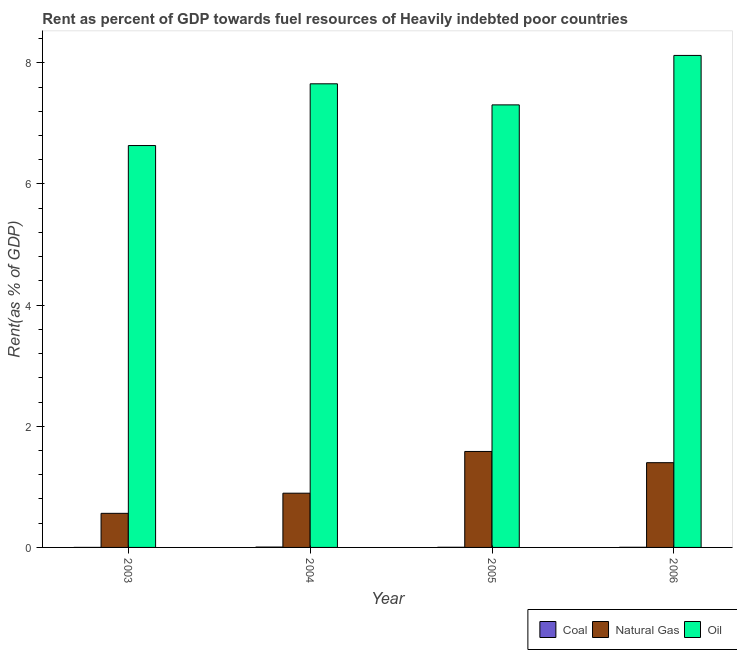How many different coloured bars are there?
Keep it short and to the point. 3. Are the number of bars per tick equal to the number of legend labels?
Your answer should be very brief. Yes. Are the number of bars on each tick of the X-axis equal?
Offer a terse response. Yes. How many bars are there on the 3rd tick from the right?
Ensure brevity in your answer.  3. In how many cases, is the number of bars for a given year not equal to the number of legend labels?
Give a very brief answer. 0. What is the rent towards natural gas in 2003?
Your answer should be compact. 0.56. Across all years, what is the maximum rent towards oil?
Offer a terse response. 8.12. Across all years, what is the minimum rent towards coal?
Offer a terse response. 0. In which year was the rent towards oil maximum?
Your answer should be compact. 2006. What is the total rent towards coal in the graph?
Your answer should be compact. 0.01. What is the difference between the rent towards natural gas in 2004 and that in 2006?
Provide a short and direct response. -0.5. What is the difference between the rent towards natural gas in 2003 and the rent towards coal in 2006?
Ensure brevity in your answer.  -0.84. What is the average rent towards oil per year?
Your response must be concise. 7.43. What is the ratio of the rent towards natural gas in 2003 to that in 2004?
Provide a short and direct response. 0.63. Is the difference between the rent towards oil in 2003 and 2006 greater than the difference between the rent towards coal in 2003 and 2006?
Your answer should be very brief. No. What is the difference between the highest and the second highest rent towards oil?
Provide a succinct answer. 0.47. What is the difference between the highest and the lowest rent towards natural gas?
Your response must be concise. 1.02. What does the 2nd bar from the left in 2004 represents?
Offer a terse response. Natural Gas. What does the 2nd bar from the right in 2006 represents?
Your response must be concise. Natural Gas. How many bars are there?
Your answer should be very brief. 12. Are all the bars in the graph horizontal?
Your response must be concise. No. What is the difference between two consecutive major ticks on the Y-axis?
Offer a terse response. 2. Are the values on the major ticks of Y-axis written in scientific E-notation?
Ensure brevity in your answer.  No. Does the graph contain any zero values?
Provide a succinct answer. No. Does the graph contain grids?
Your answer should be compact. No. Where does the legend appear in the graph?
Ensure brevity in your answer.  Bottom right. How are the legend labels stacked?
Your response must be concise. Horizontal. What is the title of the graph?
Offer a terse response. Rent as percent of GDP towards fuel resources of Heavily indebted poor countries. What is the label or title of the Y-axis?
Provide a succinct answer. Rent(as % of GDP). What is the Rent(as % of GDP) in Coal in 2003?
Your answer should be very brief. 0. What is the Rent(as % of GDP) in Natural Gas in 2003?
Offer a terse response. 0.56. What is the Rent(as % of GDP) in Oil in 2003?
Ensure brevity in your answer.  6.63. What is the Rent(as % of GDP) in Coal in 2004?
Your answer should be compact. 0.01. What is the Rent(as % of GDP) in Natural Gas in 2004?
Offer a terse response. 0.9. What is the Rent(as % of GDP) in Oil in 2004?
Your answer should be very brief. 7.65. What is the Rent(as % of GDP) in Coal in 2005?
Offer a terse response. 0. What is the Rent(as % of GDP) of Natural Gas in 2005?
Make the answer very short. 1.58. What is the Rent(as % of GDP) in Oil in 2005?
Keep it short and to the point. 7.31. What is the Rent(as % of GDP) in Coal in 2006?
Provide a short and direct response. 0. What is the Rent(as % of GDP) of Natural Gas in 2006?
Your answer should be very brief. 1.4. What is the Rent(as % of GDP) of Oil in 2006?
Your answer should be very brief. 8.12. Across all years, what is the maximum Rent(as % of GDP) of Coal?
Give a very brief answer. 0.01. Across all years, what is the maximum Rent(as % of GDP) of Natural Gas?
Ensure brevity in your answer.  1.58. Across all years, what is the maximum Rent(as % of GDP) of Oil?
Offer a very short reply. 8.12. Across all years, what is the minimum Rent(as % of GDP) in Coal?
Your answer should be compact. 0. Across all years, what is the minimum Rent(as % of GDP) in Natural Gas?
Offer a terse response. 0.56. Across all years, what is the minimum Rent(as % of GDP) of Oil?
Your response must be concise. 6.63. What is the total Rent(as % of GDP) in Coal in the graph?
Keep it short and to the point. 0.01. What is the total Rent(as % of GDP) of Natural Gas in the graph?
Your response must be concise. 4.44. What is the total Rent(as % of GDP) in Oil in the graph?
Keep it short and to the point. 29.71. What is the difference between the Rent(as % of GDP) in Coal in 2003 and that in 2004?
Ensure brevity in your answer.  -0.01. What is the difference between the Rent(as % of GDP) in Natural Gas in 2003 and that in 2004?
Provide a short and direct response. -0.33. What is the difference between the Rent(as % of GDP) of Oil in 2003 and that in 2004?
Keep it short and to the point. -1.02. What is the difference between the Rent(as % of GDP) in Coal in 2003 and that in 2005?
Your answer should be compact. -0. What is the difference between the Rent(as % of GDP) of Natural Gas in 2003 and that in 2005?
Ensure brevity in your answer.  -1.02. What is the difference between the Rent(as % of GDP) in Oil in 2003 and that in 2005?
Offer a terse response. -0.67. What is the difference between the Rent(as % of GDP) of Coal in 2003 and that in 2006?
Your answer should be compact. -0. What is the difference between the Rent(as % of GDP) in Natural Gas in 2003 and that in 2006?
Provide a short and direct response. -0.84. What is the difference between the Rent(as % of GDP) in Oil in 2003 and that in 2006?
Provide a succinct answer. -1.49. What is the difference between the Rent(as % of GDP) in Coal in 2004 and that in 2005?
Give a very brief answer. 0. What is the difference between the Rent(as % of GDP) of Natural Gas in 2004 and that in 2005?
Offer a very short reply. -0.69. What is the difference between the Rent(as % of GDP) of Oil in 2004 and that in 2005?
Provide a short and direct response. 0.35. What is the difference between the Rent(as % of GDP) of Coal in 2004 and that in 2006?
Keep it short and to the point. 0. What is the difference between the Rent(as % of GDP) in Natural Gas in 2004 and that in 2006?
Provide a succinct answer. -0.5. What is the difference between the Rent(as % of GDP) in Oil in 2004 and that in 2006?
Provide a succinct answer. -0.47. What is the difference between the Rent(as % of GDP) of Natural Gas in 2005 and that in 2006?
Offer a very short reply. 0.19. What is the difference between the Rent(as % of GDP) of Oil in 2005 and that in 2006?
Your response must be concise. -0.82. What is the difference between the Rent(as % of GDP) of Coal in 2003 and the Rent(as % of GDP) of Natural Gas in 2004?
Ensure brevity in your answer.  -0.9. What is the difference between the Rent(as % of GDP) of Coal in 2003 and the Rent(as % of GDP) of Oil in 2004?
Offer a terse response. -7.65. What is the difference between the Rent(as % of GDP) in Natural Gas in 2003 and the Rent(as % of GDP) in Oil in 2004?
Your answer should be compact. -7.09. What is the difference between the Rent(as % of GDP) of Coal in 2003 and the Rent(as % of GDP) of Natural Gas in 2005?
Your response must be concise. -1.58. What is the difference between the Rent(as % of GDP) of Coal in 2003 and the Rent(as % of GDP) of Oil in 2005?
Your answer should be very brief. -7.3. What is the difference between the Rent(as % of GDP) of Natural Gas in 2003 and the Rent(as % of GDP) of Oil in 2005?
Ensure brevity in your answer.  -6.74. What is the difference between the Rent(as % of GDP) of Coal in 2003 and the Rent(as % of GDP) of Natural Gas in 2006?
Keep it short and to the point. -1.4. What is the difference between the Rent(as % of GDP) in Coal in 2003 and the Rent(as % of GDP) in Oil in 2006?
Offer a very short reply. -8.12. What is the difference between the Rent(as % of GDP) of Natural Gas in 2003 and the Rent(as % of GDP) of Oil in 2006?
Provide a short and direct response. -7.56. What is the difference between the Rent(as % of GDP) of Coal in 2004 and the Rent(as % of GDP) of Natural Gas in 2005?
Provide a succinct answer. -1.58. What is the difference between the Rent(as % of GDP) of Coal in 2004 and the Rent(as % of GDP) of Oil in 2005?
Your answer should be compact. -7.3. What is the difference between the Rent(as % of GDP) of Natural Gas in 2004 and the Rent(as % of GDP) of Oil in 2005?
Make the answer very short. -6.41. What is the difference between the Rent(as % of GDP) of Coal in 2004 and the Rent(as % of GDP) of Natural Gas in 2006?
Give a very brief answer. -1.39. What is the difference between the Rent(as % of GDP) of Coal in 2004 and the Rent(as % of GDP) of Oil in 2006?
Give a very brief answer. -8.12. What is the difference between the Rent(as % of GDP) in Natural Gas in 2004 and the Rent(as % of GDP) in Oil in 2006?
Your response must be concise. -7.23. What is the difference between the Rent(as % of GDP) in Coal in 2005 and the Rent(as % of GDP) in Natural Gas in 2006?
Your answer should be compact. -1.4. What is the difference between the Rent(as % of GDP) in Coal in 2005 and the Rent(as % of GDP) in Oil in 2006?
Your response must be concise. -8.12. What is the difference between the Rent(as % of GDP) in Natural Gas in 2005 and the Rent(as % of GDP) in Oil in 2006?
Offer a terse response. -6.54. What is the average Rent(as % of GDP) of Coal per year?
Your response must be concise. 0. What is the average Rent(as % of GDP) in Natural Gas per year?
Provide a succinct answer. 1.11. What is the average Rent(as % of GDP) in Oil per year?
Your response must be concise. 7.43. In the year 2003, what is the difference between the Rent(as % of GDP) of Coal and Rent(as % of GDP) of Natural Gas?
Ensure brevity in your answer.  -0.56. In the year 2003, what is the difference between the Rent(as % of GDP) in Coal and Rent(as % of GDP) in Oil?
Give a very brief answer. -6.63. In the year 2003, what is the difference between the Rent(as % of GDP) in Natural Gas and Rent(as % of GDP) in Oil?
Give a very brief answer. -6.07. In the year 2004, what is the difference between the Rent(as % of GDP) of Coal and Rent(as % of GDP) of Natural Gas?
Your answer should be compact. -0.89. In the year 2004, what is the difference between the Rent(as % of GDP) of Coal and Rent(as % of GDP) of Oil?
Your answer should be very brief. -7.65. In the year 2004, what is the difference between the Rent(as % of GDP) of Natural Gas and Rent(as % of GDP) of Oil?
Provide a succinct answer. -6.76. In the year 2005, what is the difference between the Rent(as % of GDP) of Coal and Rent(as % of GDP) of Natural Gas?
Make the answer very short. -1.58. In the year 2005, what is the difference between the Rent(as % of GDP) of Coal and Rent(as % of GDP) of Oil?
Keep it short and to the point. -7.3. In the year 2005, what is the difference between the Rent(as % of GDP) of Natural Gas and Rent(as % of GDP) of Oil?
Ensure brevity in your answer.  -5.72. In the year 2006, what is the difference between the Rent(as % of GDP) in Coal and Rent(as % of GDP) in Natural Gas?
Offer a very short reply. -1.4. In the year 2006, what is the difference between the Rent(as % of GDP) in Coal and Rent(as % of GDP) in Oil?
Your answer should be compact. -8.12. In the year 2006, what is the difference between the Rent(as % of GDP) in Natural Gas and Rent(as % of GDP) in Oil?
Give a very brief answer. -6.72. What is the ratio of the Rent(as % of GDP) of Coal in 2003 to that in 2004?
Provide a short and direct response. 0.02. What is the ratio of the Rent(as % of GDP) of Natural Gas in 2003 to that in 2004?
Offer a terse response. 0.63. What is the ratio of the Rent(as % of GDP) of Oil in 2003 to that in 2004?
Offer a very short reply. 0.87. What is the ratio of the Rent(as % of GDP) of Coal in 2003 to that in 2005?
Provide a succinct answer. 0.04. What is the ratio of the Rent(as % of GDP) of Natural Gas in 2003 to that in 2005?
Give a very brief answer. 0.36. What is the ratio of the Rent(as % of GDP) in Oil in 2003 to that in 2005?
Offer a terse response. 0.91. What is the ratio of the Rent(as % of GDP) of Coal in 2003 to that in 2006?
Make the answer very short. 0.05. What is the ratio of the Rent(as % of GDP) of Natural Gas in 2003 to that in 2006?
Ensure brevity in your answer.  0.4. What is the ratio of the Rent(as % of GDP) of Oil in 2003 to that in 2006?
Offer a very short reply. 0.82. What is the ratio of the Rent(as % of GDP) of Coal in 2004 to that in 2005?
Your response must be concise. 2.24. What is the ratio of the Rent(as % of GDP) of Natural Gas in 2004 to that in 2005?
Your answer should be compact. 0.57. What is the ratio of the Rent(as % of GDP) of Oil in 2004 to that in 2005?
Your answer should be very brief. 1.05. What is the ratio of the Rent(as % of GDP) of Coal in 2004 to that in 2006?
Provide a succinct answer. 2.52. What is the ratio of the Rent(as % of GDP) in Natural Gas in 2004 to that in 2006?
Your answer should be very brief. 0.64. What is the ratio of the Rent(as % of GDP) of Oil in 2004 to that in 2006?
Make the answer very short. 0.94. What is the ratio of the Rent(as % of GDP) in Coal in 2005 to that in 2006?
Your answer should be compact. 1.12. What is the ratio of the Rent(as % of GDP) in Natural Gas in 2005 to that in 2006?
Your answer should be very brief. 1.13. What is the ratio of the Rent(as % of GDP) in Oil in 2005 to that in 2006?
Keep it short and to the point. 0.9. What is the difference between the highest and the second highest Rent(as % of GDP) in Coal?
Offer a terse response. 0. What is the difference between the highest and the second highest Rent(as % of GDP) of Natural Gas?
Make the answer very short. 0.19. What is the difference between the highest and the second highest Rent(as % of GDP) of Oil?
Your answer should be compact. 0.47. What is the difference between the highest and the lowest Rent(as % of GDP) in Coal?
Your answer should be compact. 0.01. What is the difference between the highest and the lowest Rent(as % of GDP) in Natural Gas?
Make the answer very short. 1.02. What is the difference between the highest and the lowest Rent(as % of GDP) in Oil?
Keep it short and to the point. 1.49. 